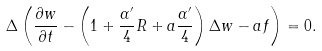Convert formula to latex. <formula><loc_0><loc_0><loc_500><loc_500>\Delta \left ( \frac { \partial w } { \partial t } - \left ( 1 + \frac { \alpha ^ { \prime } } { 4 } R + a \frac { \alpha ^ { \prime } } { 4 } \right ) \Delta w - a f \right ) = 0 .</formula> 